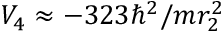Convert formula to latex. <formula><loc_0><loc_0><loc_500><loc_500>V _ { 4 } \approx - 3 2 3 \hbar { ^ } { 2 } / m r _ { 2 } ^ { 2 }</formula> 